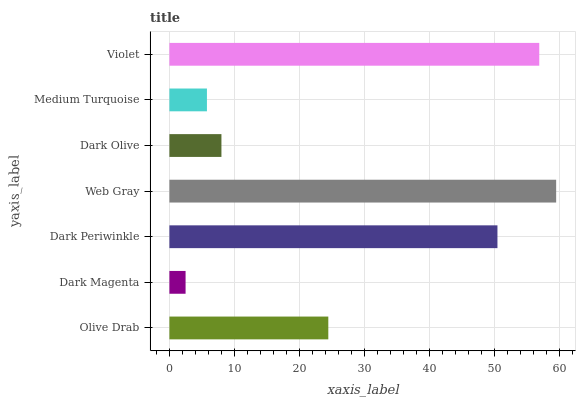Is Dark Magenta the minimum?
Answer yes or no. Yes. Is Web Gray the maximum?
Answer yes or no. Yes. Is Dark Periwinkle the minimum?
Answer yes or no. No. Is Dark Periwinkle the maximum?
Answer yes or no. No. Is Dark Periwinkle greater than Dark Magenta?
Answer yes or no. Yes. Is Dark Magenta less than Dark Periwinkle?
Answer yes or no. Yes. Is Dark Magenta greater than Dark Periwinkle?
Answer yes or no. No. Is Dark Periwinkle less than Dark Magenta?
Answer yes or no. No. Is Olive Drab the high median?
Answer yes or no. Yes. Is Olive Drab the low median?
Answer yes or no. Yes. Is Dark Olive the high median?
Answer yes or no. No. Is Dark Olive the low median?
Answer yes or no. No. 